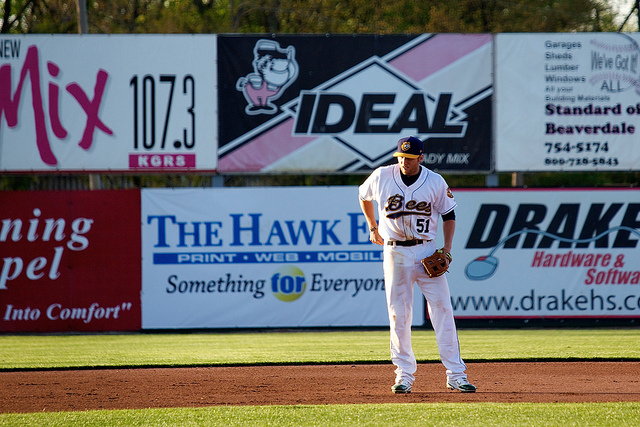Identify the text displayed in this image. THE HAWK 51 Hardware Softwa for 0007105043 754-5174 Beaverdale oi Standard ALL Sheas Garages &amp; hardware Bees www.drakehs.com Everyon MOBIL WEB Something PRINT Comfort" Into pel ning IDEAL 107.3 Mix EW 